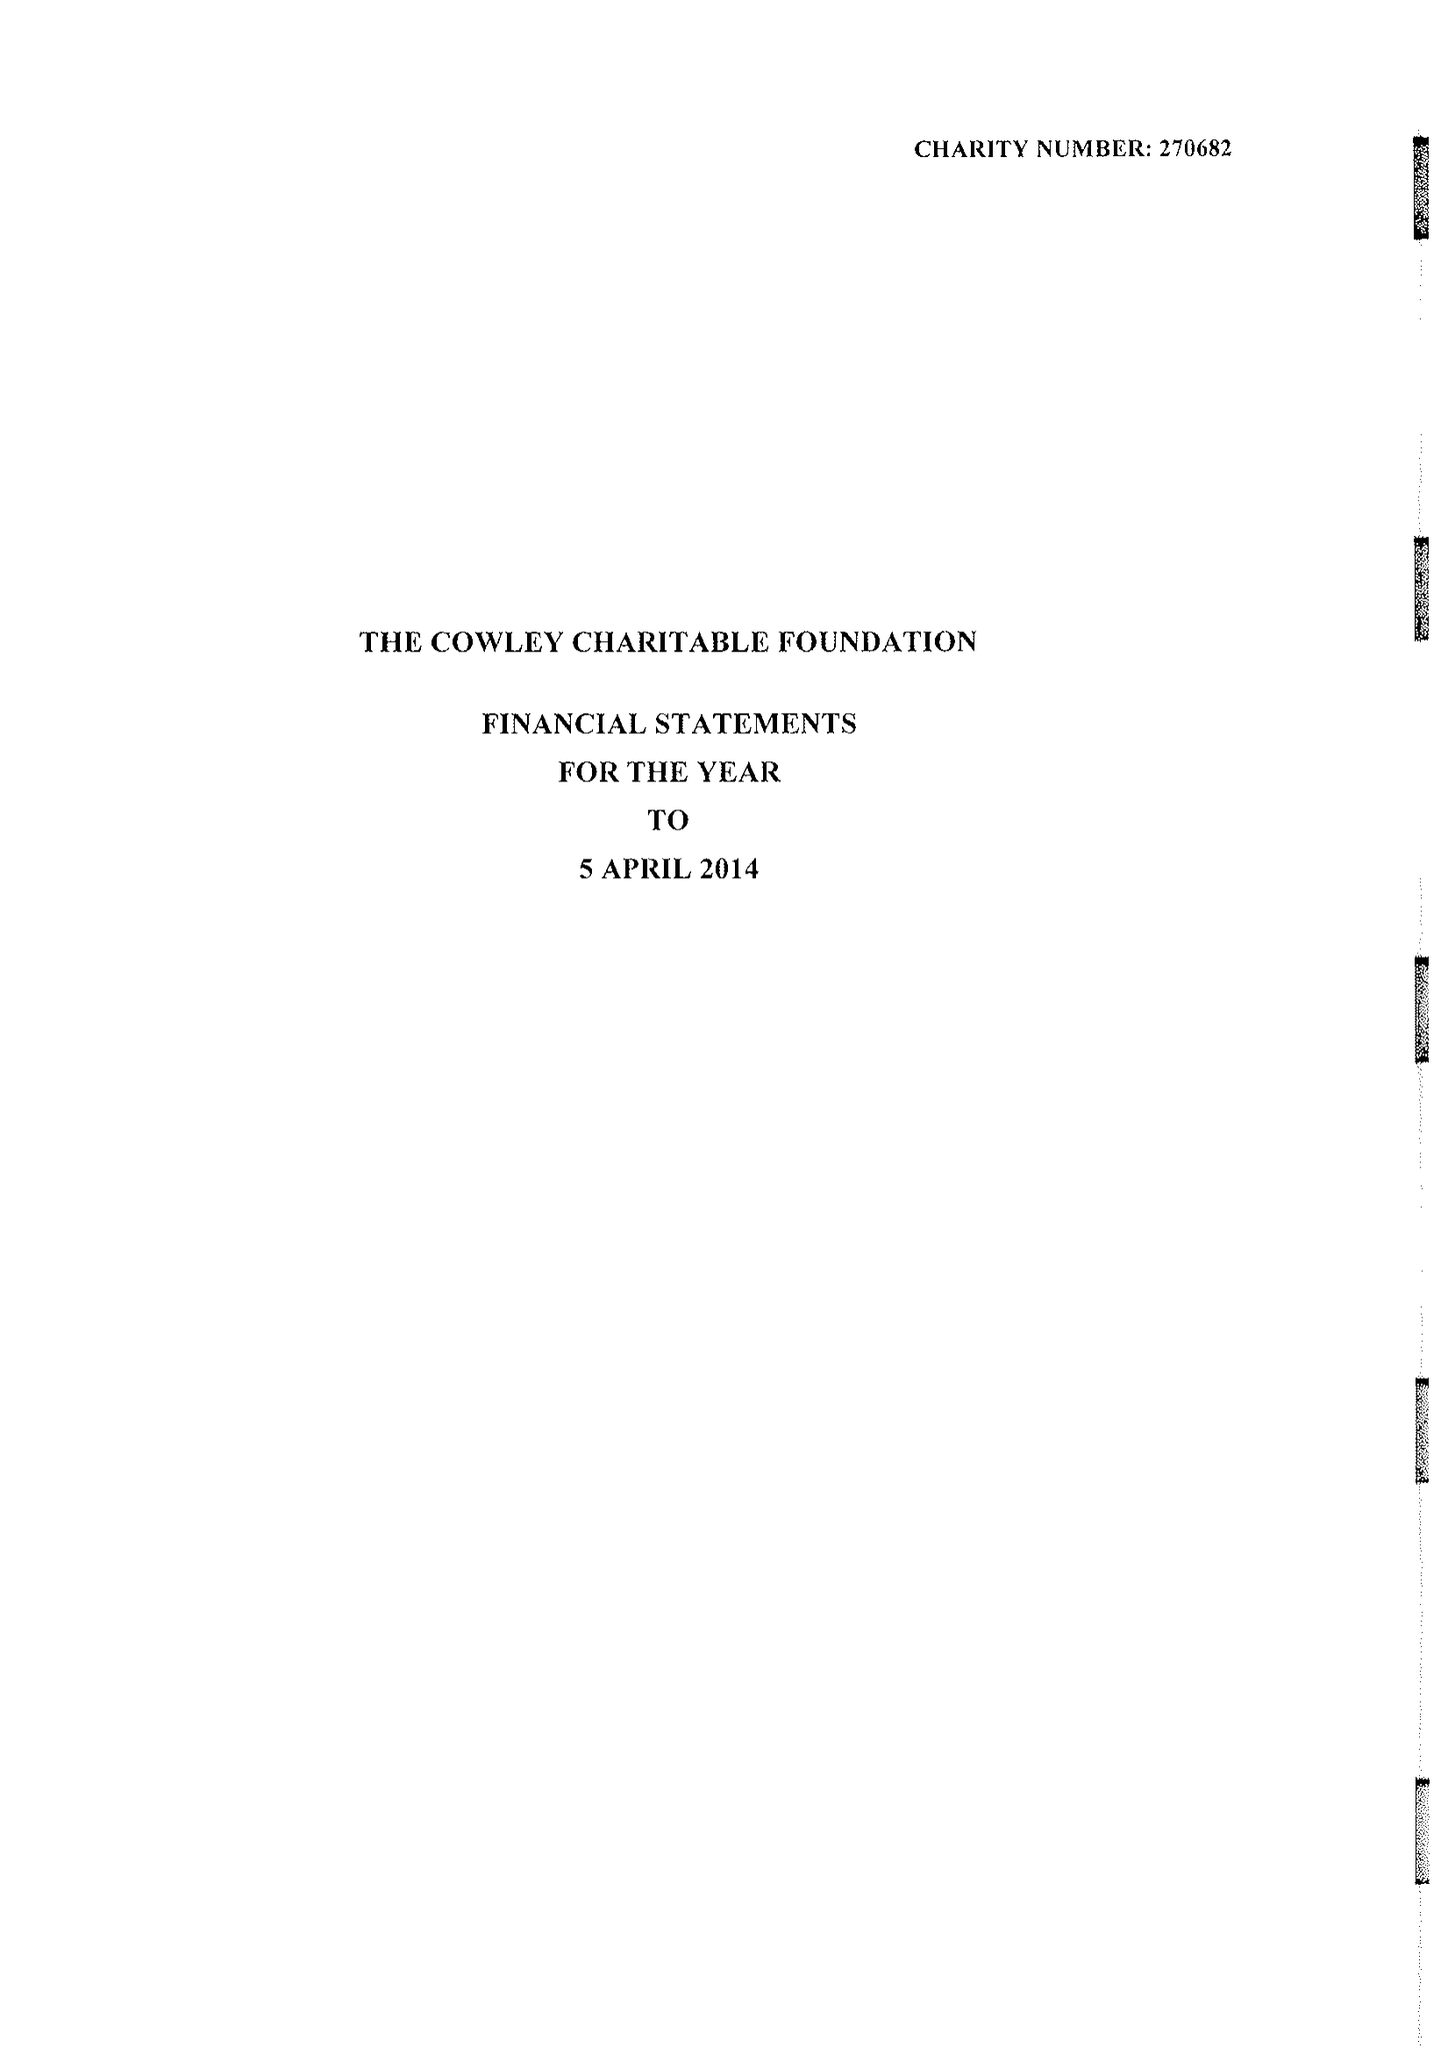What is the value for the charity_name?
Answer the question using a single word or phrase. The Cowley Charitable Foundation 